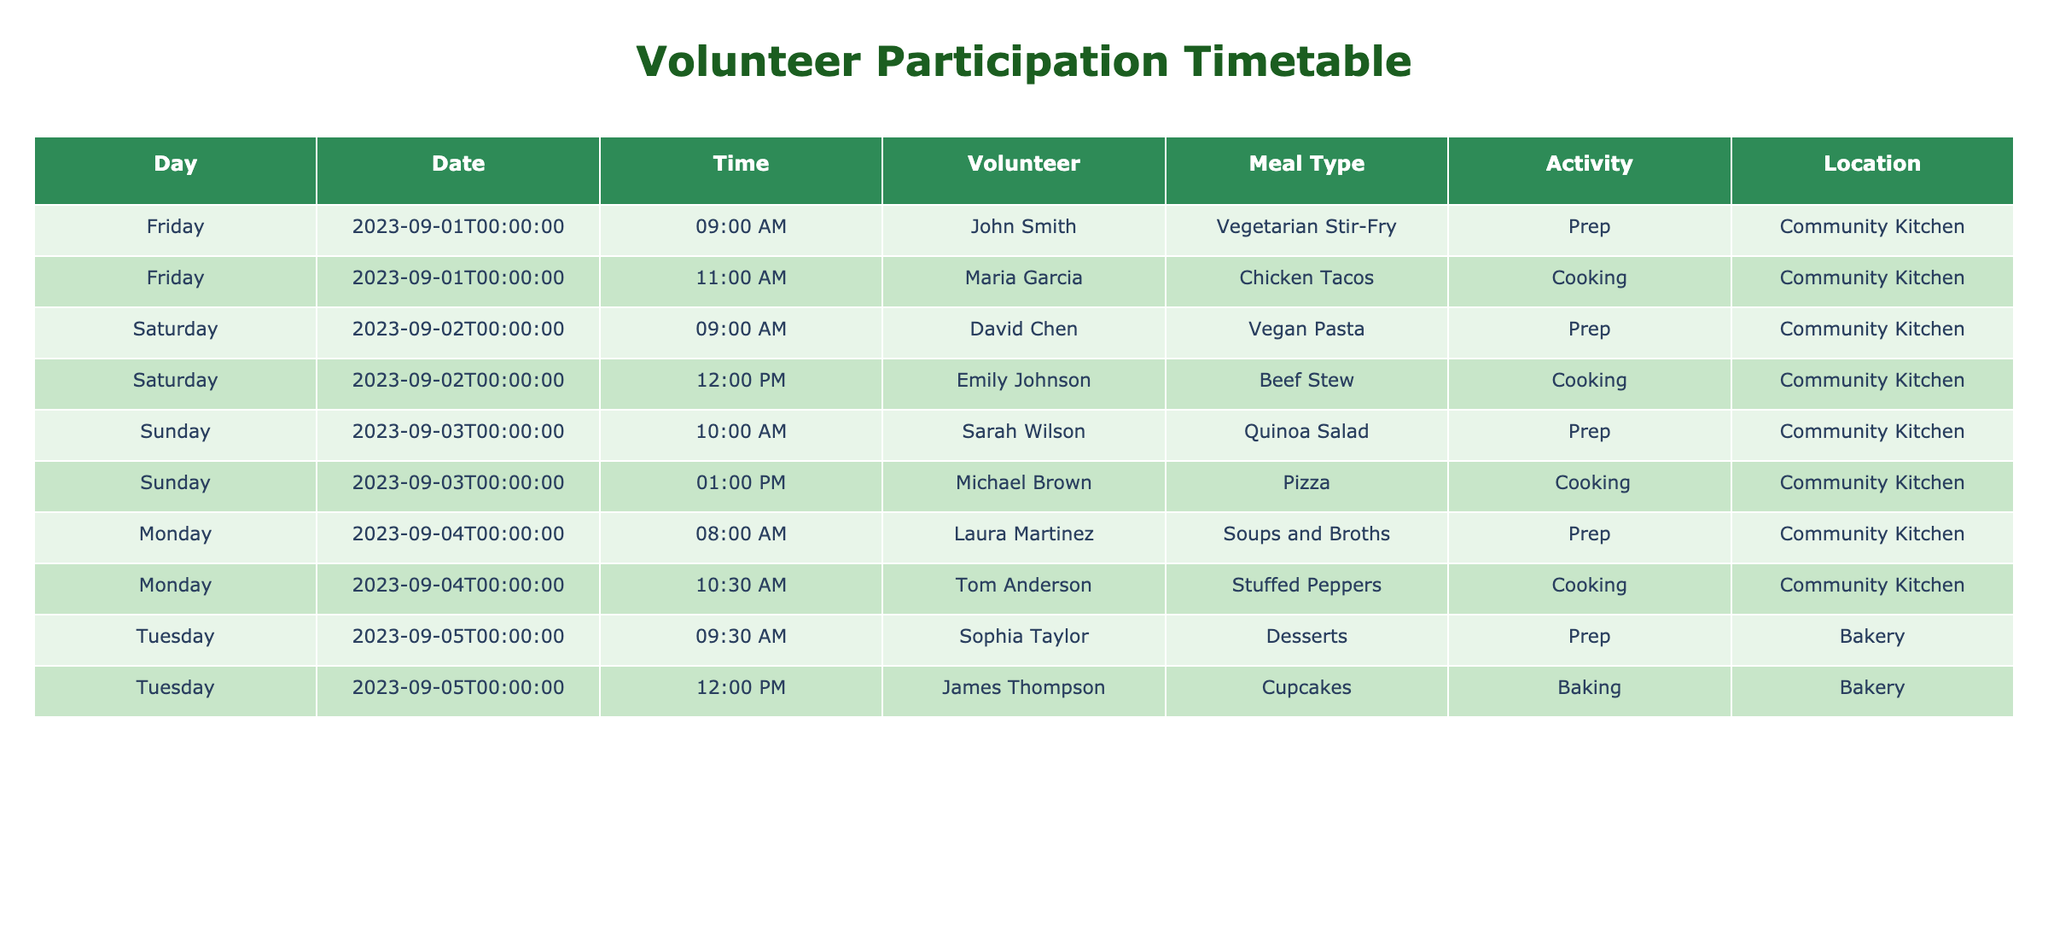What meal did Emily Johnson prepare? The table shows that Emily Johnson was involved in a meal activity on September 2, where she cooked Beef Stew. This information is directly visible in the corresponding row in the table.
Answer: Beef Stew How many different meal types were prepared on September 1st? By examining the rows for September 1st, I find two different meal types: Vegetarian Stir-Fry prepared by John Smith and Chicken Tacos cooked by Maria Garcia, which makes a total of two meal types for that day.
Answer: 2 Did any volunteers prepare desserts? Looking through the activity column, I see that Sophia Taylor prepared Desserts, indicating that there is at least one volunteer who participated in dessert preparation.
Answer: Yes Which meal type was prepared at the Bakery, and who was the volunteer? The table lists one meal at the Bakery, which was Desserts, prepared by Sophia Taylor. This information is found in the row that mentions the Bakery as the location.
Answer: Desserts, Sophia Taylor On which day were the most activities conducted, and how many activities were there? By counting the number of activities listed per day, September 1st has 2 activities (Vegetarian Stir-Fry and Chicken Tacos), September 2nd has 2 activities (Vegan Pasta and Beef Stew), September 3rd has 2 activities (Quinoa Salad and Pizza), September 4th has 2 activities (Soups and Broths and Stuffed Peppers), and September 5th has 2 activities (Desserts and Cupcakes). Therefore, all days had an equal number of activities at 2.
Answer: September 1st, 2 activities What is the location where Tom Anderson cooked? The table shows that Tom Anderson was involved in cooking Stuffed Peppers on September 4, and the location specified in the table is the Community Kitchen.
Answer: Community Kitchen 